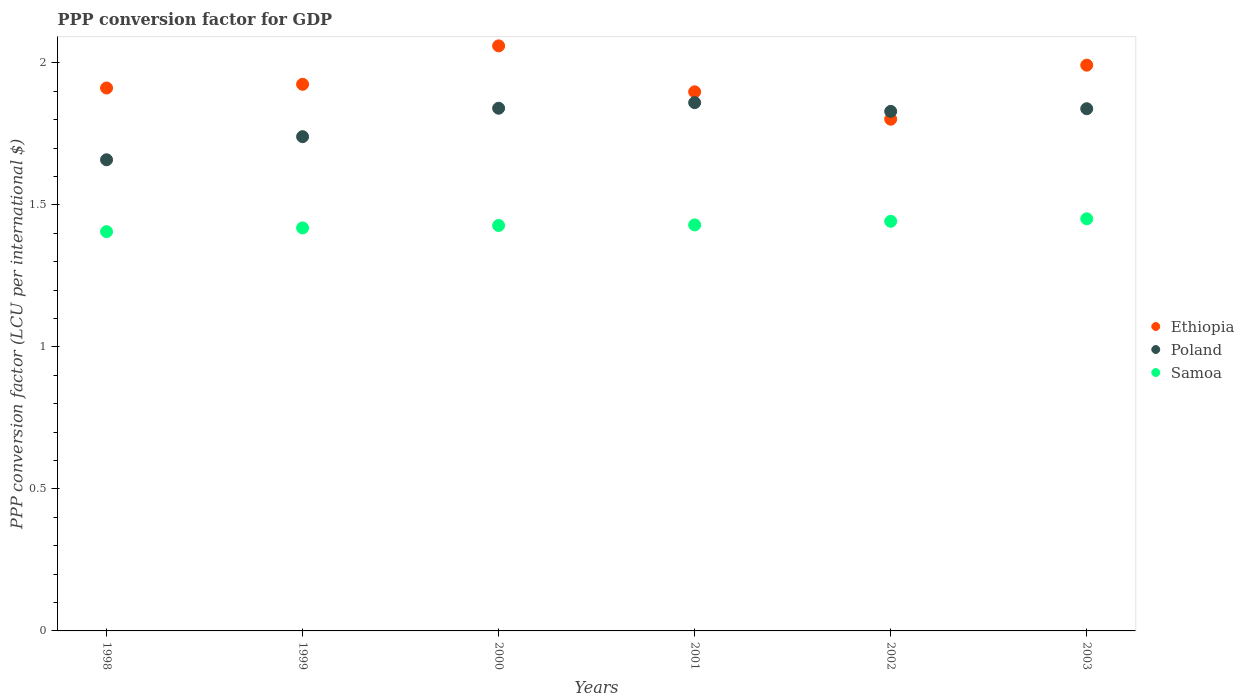How many different coloured dotlines are there?
Offer a terse response. 3. What is the PPP conversion factor for GDP in Poland in 2003?
Your answer should be compact. 1.84. Across all years, what is the maximum PPP conversion factor for GDP in Samoa?
Offer a terse response. 1.45. Across all years, what is the minimum PPP conversion factor for GDP in Ethiopia?
Provide a short and direct response. 1.8. In which year was the PPP conversion factor for GDP in Ethiopia minimum?
Keep it short and to the point. 2002. What is the total PPP conversion factor for GDP in Ethiopia in the graph?
Your response must be concise. 11.59. What is the difference between the PPP conversion factor for GDP in Ethiopia in 1998 and that in 1999?
Keep it short and to the point. -0.01. What is the difference between the PPP conversion factor for GDP in Samoa in 2002 and the PPP conversion factor for GDP in Ethiopia in 2003?
Your answer should be very brief. -0.55. What is the average PPP conversion factor for GDP in Poland per year?
Give a very brief answer. 1.79. In the year 2002, what is the difference between the PPP conversion factor for GDP in Samoa and PPP conversion factor for GDP in Poland?
Keep it short and to the point. -0.39. What is the ratio of the PPP conversion factor for GDP in Ethiopia in 1999 to that in 2003?
Your answer should be very brief. 0.97. What is the difference between the highest and the second highest PPP conversion factor for GDP in Poland?
Your answer should be compact. 0.02. What is the difference between the highest and the lowest PPP conversion factor for GDP in Ethiopia?
Make the answer very short. 0.26. In how many years, is the PPP conversion factor for GDP in Ethiopia greater than the average PPP conversion factor for GDP in Ethiopia taken over all years?
Ensure brevity in your answer.  2. Is the PPP conversion factor for GDP in Samoa strictly greater than the PPP conversion factor for GDP in Poland over the years?
Your response must be concise. No. Is the PPP conversion factor for GDP in Ethiopia strictly less than the PPP conversion factor for GDP in Poland over the years?
Your response must be concise. No. How many dotlines are there?
Make the answer very short. 3. What is the difference between two consecutive major ticks on the Y-axis?
Offer a terse response. 0.5. Are the values on the major ticks of Y-axis written in scientific E-notation?
Give a very brief answer. No. Does the graph contain any zero values?
Ensure brevity in your answer.  No. Where does the legend appear in the graph?
Make the answer very short. Center right. What is the title of the graph?
Give a very brief answer. PPP conversion factor for GDP. Does "Euro area" appear as one of the legend labels in the graph?
Offer a very short reply. No. What is the label or title of the Y-axis?
Keep it short and to the point. PPP conversion factor (LCU per international $). What is the PPP conversion factor (LCU per international $) in Ethiopia in 1998?
Offer a very short reply. 1.91. What is the PPP conversion factor (LCU per international $) of Poland in 1998?
Your answer should be very brief. 1.66. What is the PPP conversion factor (LCU per international $) in Samoa in 1998?
Provide a short and direct response. 1.41. What is the PPP conversion factor (LCU per international $) in Ethiopia in 1999?
Your answer should be very brief. 1.92. What is the PPP conversion factor (LCU per international $) in Poland in 1999?
Ensure brevity in your answer.  1.74. What is the PPP conversion factor (LCU per international $) of Samoa in 1999?
Give a very brief answer. 1.42. What is the PPP conversion factor (LCU per international $) in Ethiopia in 2000?
Give a very brief answer. 2.06. What is the PPP conversion factor (LCU per international $) of Poland in 2000?
Provide a succinct answer. 1.84. What is the PPP conversion factor (LCU per international $) in Samoa in 2000?
Your response must be concise. 1.43. What is the PPP conversion factor (LCU per international $) of Ethiopia in 2001?
Make the answer very short. 1.9. What is the PPP conversion factor (LCU per international $) of Poland in 2001?
Provide a succinct answer. 1.86. What is the PPP conversion factor (LCU per international $) of Samoa in 2001?
Your answer should be very brief. 1.43. What is the PPP conversion factor (LCU per international $) of Ethiopia in 2002?
Offer a very short reply. 1.8. What is the PPP conversion factor (LCU per international $) of Poland in 2002?
Provide a succinct answer. 1.83. What is the PPP conversion factor (LCU per international $) of Samoa in 2002?
Offer a very short reply. 1.44. What is the PPP conversion factor (LCU per international $) of Ethiopia in 2003?
Ensure brevity in your answer.  1.99. What is the PPP conversion factor (LCU per international $) in Poland in 2003?
Give a very brief answer. 1.84. What is the PPP conversion factor (LCU per international $) in Samoa in 2003?
Your response must be concise. 1.45. Across all years, what is the maximum PPP conversion factor (LCU per international $) of Ethiopia?
Ensure brevity in your answer.  2.06. Across all years, what is the maximum PPP conversion factor (LCU per international $) of Poland?
Keep it short and to the point. 1.86. Across all years, what is the maximum PPP conversion factor (LCU per international $) in Samoa?
Your answer should be very brief. 1.45. Across all years, what is the minimum PPP conversion factor (LCU per international $) of Ethiopia?
Your answer should be compact. 1.8. Across all years, what is the minimum PPP conversion factor (LCU per international $) of Poland?
Provide a succinct answer. 1.66. Across all years, what is the minimum PPP conversion factor (LCU per international $) of Samoa?
Your answer should be compact. 1.41. What is the total PPP conversion factor (LCU per international $) in Ethiopia in the graph?
Give a very brief answer. 11.59. What is the total PPP conversion factor (LCU per international $) in Poland in the graph?
Your response must be concise. 10.77. What is the total PPP conversion factor (LCU per international $) of Samoa in the graph?
Ensure brevity in your answer.  8.57. What is the difference between the PPP conversion factor (LCU per international $) of Ethiopia in 1998 and that in 1999?
Provide a short and direct response. -0.01. What is the difference between the PPP conversion factor (LCU per international $) in Poland in 1998 and that in 1999?
Your answer should be very brief. -0.08. What is the difference between the PPP conversion factor (LCU per international $) in Samoa in 1998 and that in 1999?
Your answer should be very brief. -0.01. What is the difference between the PPP conversion factor (LCU per international $) in Ethiopia in 1998 and that in 2000?
Give a very brief answer. -0.15. What is the difference between the PPP conversion factor (LCU per international $) in Poland in 1998 and that in 2000?
Keep it short and to the point. -0.18. What is the difference between the PPP conversion factor (LCU per international $) of Samoa in 1998 and that in 2000?
Provide a succinct answer. -0.02. What is the difference between the PPP conversion factor (LCU per international $) in Ethiopia in 1998 and that in 2001?
Provide a succinct answer. 0.01. What is the difference between the PPP conversion factor (LCU per international $) of Poland in 1998 and that in 2001?
Offer a terse response. -0.2. What is the difference between the PPP conversion factor (LCU per international $) of Samoa in 1998 and that in 2001?
Offer a terse response. -0.02. What is the difference between the PPP conversion factor (LCU per international $) in Ethiopia in 1998 and that in 2002?
Offer a very short reply. 0.11. What is the difference between the PPP conversion factor (LCU per international $) in Poland in 1998 and that in 2002?
Ensure brevity in your answer.  -0.17. What is the difference between the PPP conversion factor (LCU per international $) in Samoa in 1998 and that in 2002?
Your response must be concise. -0.04. What is the difference between the PPP conversion factor (LCU per international $) in Ethiopia in 1998 and that in 2003?
Offer a terse response. -0.08. What is the difference between the PPP conversion factor (LCU per international $) in Poland in 1998 and that in 2003?
Your response must be concise. -0.18. What is the difference between the PPP conversion factor (LCU per international $) of Samoa in 1998 and that in 2003?
Your answer should be compact. -0.05. What is the difference between the PPP conversion factor (LCU per international $) in Ethiopia in 1999 and that in 2000?
Ensure brevity in your answer.  -0.14. What is the difference between the PPP conversion factor (LCU per international $) in Poland in 1999 and that in 2000?
Offer a terse response. -0.1. What is the difference between the PPP conversion factor (LCU per international $) of Samoa in 1999 and that in 2000?
Provide a short and direct response. -0.01. What is the difference between the PPP conversion factor (LCU per international $) of Ethiopia in 1999 and that in 2001?
Your answer should be compact. 0.03. What is the difference between the PPP conversion factor (LCU per international $) in Poland in 1999 and that in 2001?
Keep it short and to the point. -0.12. What is the difference between the PPP conversion factor (LCU per international $) in Samoa in 1999 and that in 2001?
Provide a succinct answer. -0.01. What is the difference between the PPP conversion factor (LCU per international $) of Ethiopia in 1999 and that in 2002?
Your answer should be compact. 0.12. What is the difference between the PPP conversion factor (LCU per international $) of Poland in 1999 and that in 2002?
Offer a terse response. -0.09. What is the difference between the PPP conversion factor (LCU per international $) in Samoa in 1999 and that in 2002?
Keep it short and to the point. -0.02. What is the difference between the PPP conversion factor (LCU per international $) in Ethiopia in 1999 and that in 2003?
Ensure brevity in your answer.  -0.07. What is the difference between the PPP conversion factor (LCU per international $) in Poland in 1999 and that in 2003?
Offer a terse response. -0.1. What is the difference between the PPP conversion factor (LCU per international $) of Samoa in 1999 and that in 2003?
Provide a succinct answer. -0.03. What is the difference between the PPP conversion factor (LCU per international $) in Ethiopia in 2000 and that in 2001?
Keep it short and to the point. 0.16. What is the difference between the PPP conversion factor (LCU per international $) of Poland in 2000 and that in 2001?
Provide a short and direct response. -0.02. What is the difference between the PPP conversion factor (LCU per international $) in Samoa in 2000 and that in 2001?
Your answer should be compact. -0. What is the difference between the PPP conversion factor (LCU per international $) of Ethiopia in 2000 and that in 2002?
Provide a succinct answer. 0.26. What is the difference between the PPP conversion factor (LCU per international $) of Poland in 2000 and that in 2002?
Provide a short and direct response. 0.01. What is the difference between the PPP conversion factor (LCU per international $) of Samoa in 2000 and that in 2002?
Make the answer very short. -0.01. What is the difference between the PPP conversion factor (LCU per international $) in Ethiopia in 2000 and that in 2003?
Offer a very short reply. 0.07. What is the difference between the PPP conversion factor (LCU per international $) of Poland in 2000 and that in 2003?
Keep it short and to the point. 0. What is the difference between the PPP conversion factor (LCU per international $) of Samoa in 2000 and that in 2003?
Keep it short and to the point. -0.02. What is the difference between the PPP conversion factor (LCU per international $) in Ethiopia in 2001 and that in 2002?
Your answer should be very brief. 0.1. What is the difference between the PPP conversion factor (LCU per international $) in Poland in 2001 and that in 2002?
Give a very brief answer. 0.03. What is the difference between the PPP conversion factor (LCU per international $) in Samoa in 2001 and that in 2002?
Offer a very short reply. -0.01. What is the difference between the PPP conversion factor (LCU per international $) in Ethiopia in 2001 and that in 2003?
Provide a succinct answer. -0.09. What is the difference between the PPP conversion factor (LCU per international $) of Poland in 2001 and that in 2003?
Provide a short and direct response. 0.02. What is the difference between the PPP conversion factor (LCU per international $) of Samoa in 2001 and that in 2003?
Offer a very short reply. -0.02. What is the difference between the PPP conversion factor (LCU per international $) of Ethiopia in 2002 and that in 2003?
Your response must be concise. -0.19. What is the difference between the PPP conversion factor (LCU per international $) of Poland in 2002 and that in 2003?
Your answer should be compact. -0.01. What is the difference between the PPP conversion factor (LCU per international $) in Samoa in 2002 and that in 2003?
Offer a very short reply. -0.01. What is the difference between the PPP conversion factor (LCU per international $) in Ethiopia in 1998 and the PPP conversion factor (LCU per international $) in Poland in 1999?
Keep it short and to the point. 0.17. What is the difference between the PPP conversion factor (LCU per international $) in Ethiopia in 1998 and the PPP conversion factor (LCU per international $) in Samoa in 1999?
Give a very brief answer. 0.49. What is the difference between the PPP conversion factor (LCU per international $) in Poland in 1998 and the PPP conversion factor (LCU per international $) in Samoa in 1999?
Your answer should be very brief. 0.24. What is the difference between the PPP conversion factor (LCU per international $) in Ethiopia in 1998 and the PPP conversion factor (LCU per international $) in Poland in 2000?
Your response must be concise. 0.07. What is the difference between the PPP conversion factor (LCU per international $) in Ethiopia in 1998 and the PPP conversion factor (LCU per international $) in Samoa in 2000?
Keep it short and to the point. 0.48. What is the difference between the PPP conversion factor (LCU per international $) in Poland in 1998 and the PPP conversion factor (LCU per international $) in Samoa in 2000?
Offer a terse response. 0.23. What is the difference between the PPP conversion factor (LCU per international $) in Ethiopia in 1998 and the PPP conversion factor (LCU per international $) in Poland in 2001?
Provide a succinct answer. 0.05. What is the difference between the PPP conversion factor (LCU per international $) of Ethiopia in 1998 and the PPP conversion factor (LCU per international $) of Samoa in 2001?
Make the answer very short. 0.48. What is the difference between the PPP conversion factor (LCU per international $) of Poland in 1998 and the PPP conversion factor (LCU per international $) of Samoa in 2001?
Your response must be concise. 0.23. What is the difference between the PPP conversion factor (LCU per international $) of Ethiopia in 1998 and the PPP conversion factor (LCU per international $) of Poland in 2002?
Make the answer very short. 0.08. What is the difference between the PPP conversion factor (LCU per international $) of Ethiopia in 1998 and the PPP conversion factor (LCU per international $) of Samoa in 2002?
Your answer should be very brief. 0.47. What is the difference between the PPP conversion factor (LCU per international $) in Poland in 1998 and the PPP conversion factor (LCU per international $) in Samoa in 2002?
Give a very brief answer. 0.22. What is the difference between the PPP conversion factor (LCU per international $) in Ethiopia in 1998 and the PPP conversion factor (LCU per international $) in Poland in 2003?
Keep it short and to the point. 0.07. What is the difference between the PPP conversion factor (LCU per international $) of Ethiopia in 1998 and the PPP conversion factor (LCU per international $) of Samoa in 2003?
Provide a short and direct response. 0.46. What is the difference between the PPP conversion factor (LCU per international $) in Poland in 1998 and the PPP conversion factor (LCU per international $) in Samoa in 2003?
Offer a very short reply. 0.21. What is the difference between the PPP conversion factor (LCU per international $) of Ethiopia in 1999 and the PPP conversion factor (LCU per international $) of Poland in 2000?
Keep it short and to the point. 0.08. What is the difference between the PPP conversion factor (LCU per international $) of Ethiopia in 1999 and the PPP conversion factor (LCU per international $) of Samoa in 2000?
Your response must be concise. 0.5. What is the difference between the PPP conversion factor (LCU per international $) of Poland in 1999 and the PPP conversion factor (LCU per international $) of Samoa in 2000?
Your answer should be compact. 0.31. What is the difference between the PPP conversion factor (LCU per international $) of Ethiopia in 1999 and the PPP conversion factor (LCU per international $) of Poland in 2001?
Provide a succinct answer. 0.06. What is the difference between the PPP conversion factor (LCU per international $) of Ethiopia in 1999 and the PPP conversion factor (LCU per international $) of Samoa in 2001?
Provide a succinct answer. 0.49. What is the difference between the PPP conversion factor (LCU per international $) in Poland in 1999 and the PPP conversion factor (LCU per international $) in Samoa in 2001?
Your answer should be very brief. 0.31. What is the difference between the PPP conversion factor (LCU per international $) in Ethiopia in 1999 and the PPP conversion factor (LCU per international $) in Poland in 2002?
Give a very brief answer. 0.1. What is the difference between the PPP conversion factor (LCU per international $) in Ethiopia in 1999 and the PPP conversion factor (LCU per international $) in Samoa in 2002?
Provide a short and direct response. 0.48. What is the difference between the PPP conversion factor (LCU per international $) of Poland in 1999 and the PPP conversion factor (LCU per international $) of Samoa in 2002?
Provide a short and direct response. 0.3. What is the difference between the PPP conversion factor (LCU per international $) of Ethiopia in 1999 and the PPP conversion factor (LCU per international $) of Poland in 2003?
Make the answer very short. 0.09. What is the difference between the PPP conversion factor (LCU per international $) in Ethiopia in 1999 and the PPP conversion factor (LCU per international $) in Samoa in 2003?
Offer a terse response. 0.47. What is the difference between the PPP conversion factor (LCU per international $) of Poland in 1999 and the PPP conversion factor (LCU per international $) of Samoa in 2003?
Make the answer very short. 0.29. What is the difference between the PPP conversion factor (LCU per international $) in Ethiopia in 2000 and the PPP conversion factor (LCU per international $) in Poland in 2001?
Ensure brevity in your answer.  0.2. What is the difference between the PPP conversion factor (LCU per international $) in Ethiopia in 2000 and the PPP conversion factor (LCU per international $) in Samoa in 2001?
Provide a short and direct response. 0.63. What is the difference between the PPP conversion factor (LCU per international $) of Poland in 2000 and the PPP conversion factor (LCU per international $) of Samoa in 2001?
Offer a very short reply. 0.41. What is the difference between the PPP conversion factor (LCU per international $) of Ethiopia in 2000 and the PPP conversion factor (LCU per international $) of Poland in 2002?
Provide a succinct answer. 0.23. What is the difference between the PPP conversion factor (LCU per international $) in Ethiopia in 2000 and the PPP conversion factor (LCU per international $) in Samoa in 2002?
Your response must be concise. 0.62. What is the difference between the PPP conversion factor (LCU per international $) of Poland in 2000 and the PPP conversion factor (LCU per international $) of Samoa in 2002?
Make the answer very short. 0.4. What is the difference between the PPP conversion factor (LCU per international $) of Ethiopia in 2000 and the PPP conversion factor (LCU per international $) of Poland in 2003?
Offer a terse response. 0.22. What is the difference between the PPP conversion factor (LCU per international $) in Ethiopia in 2000 and the PPP conversion factor (LCU per international $) in Samoa in 2003?
Make the answer very short. 0.61. What is the difference between the PPP conversion factor (LCU per international $) of Poland in 2000 and the PPP conversion factor (LCU per international $) of Samoa in 2003?
Provide a succinct answer. 0.39. What is the difference between the PPP conversion factor (LCU per international $) of Ethiopia in 2001 and the PPP conversion factor (LCU per international $) of Poland in 2002?
Ensure brevity in your answer.  0.07. What is the difference between the PPP conversion factor (LCU per international $) of Ethiopia in 2001 and the PPP conversion factor (LCU per international $) of Samoa in 2002?
Offer a very short reply. 0.46. What is the difference between the PPP conversion factor (LCU per international $) of Poland in 2001 and the PPP conversion factor (LCU per international $) of Samoa in 2002?
Provide a succinct answer. 0.42. What is the difference between the PPP conversion factor (LCU per international $) of Ethiopia in 2001 and the PPP conversion factor (LCU per international $) of Poland in 2003?
Offer a very short reply. 0.06. What is the difference between the PPP conversion factor (LCU per international $) in Ethiopia in 2001 and the PPP conversion factor (LCU per international $) in Samoa in 2003?
Ensure brevity in your answer.  0.45. What is the difference between the PPP conversion factor (LCU per international $) in Poland in 2001 and the PPP conversion factor (LCU per international $) in Samoa in 2003?
Your response must be concise. 0.41. What is the difference between the PPP conversion factor (LCU per international $) of Ethiopia in 2002 and the PPP conversion factor (LCU per international $) of Poland in 2003?
Provide a short and direct response. -0.04. What is the difference between the PPP conversion factor (LCU per international $) in Ethiopia in 2002 and the PPP conversion factor (LCU per international $) in Samoa in 2003?
Your answer should be very brief. 0.35. What is the difference between the PPP conversion factor (LCU per international $) in Poland in 2002 and the PPP conversion factor (LCU per international $) in Samoa in 2003?
Provide a short and direct response. 0.38. What is the average PPP conversion factor (LCU per international $) in Ethiopia per year?
Provide a succinct answer. 1.93. What is the average PPP conversion factor (LCU per international $) in Poland per year?
Provide a succinct answer. 1.79. What is the average PPP conversion factor (LCU per international $) in Samoa per year?
Your answer should be very brief. 1.43. In the year 1998, what is the difference between the PPP conversion factor (LCU per international $) in Ethiopia and PPP conversion factor (LCU per international $) in Poland?
Your response must be concise. 0.25. In the year 1998, what is the difference between the PPP conversion factor (LCU per international $) in Ethiopia and PPP conversion factor (LCU per international $) in Samoa?
Give a very brief answer. 0.51. In the year 1998, what is the difference between the PPP conversion factor (LCU per international $) in Poland and PPP conversion factor (LCU per international $) in Samoa?
Your response must be concise. 0.25. In the year 1999, what is the difference between the PPP conversion factor (LCU per international $) of Ethiopia and PPP conversion factor (LCU per international $) of Poland?
Your answer should be compact. 0.18. In the year 1999, what is the difference between the PPP conversion factor (LCU per international $) of Ethiopia and PPP conversion factor (LCU per international $) of Samoa?
Provide a short and direct response. 0.51. In the year 1999, what is the difference between the PPP conversion factor (LCU per international $) in Poland and PPP conversion factor (LCU per international $) in Samoa?
Offer a very short reply. 0.32. In the year 2000, what is the difference between the PPP conversion factor (LCU per international $) in Ethiopia and PPP conversion factor (LCU per international $) in Poland?
Ensure brevity in your answer.  0.22. In the year 2000, what is the difference between the PPP conversion factor (LCU per international $) of Ethiopia and PPP conversion factor (LCU per international $) of Samoa?
Make the answer very short. 0.63. In the year 2000, what is the difference between the PPP conversion factor (LCU per international $) of Poland and PPP conversion factor (LCU per international $) of Samoa?
Keep it short and to the point. 0.41. In the year 2001, what is the difference between the PPP conversion factor (LCU per international $) in Ethiopia and PPP conversion factor (LCU per international $) in Poland?
Your response must be concise. 0.04. In the year 2001, what is the difference between the PPP conversion factor (LCU per international $) of Ethiopia and PPP conversion factor (LCU per international $) of Samoa?
Your response must be concise. 0.47. In the year 2001, what is the difference between the PPP conversion factor (LCU per international $) in Poland and PPP conversion factor (LCU per international $) in Samoa?
Your answer should be very brief. 0.43. In the year 2002, what is the difference between the PPP conversion factor (LCU per international $) in Ethiopia and PPP conversion factor (LCU per international $) in Poland?
Make the answer very short. -0.03. In the year 2002, what is the difference between the PPP conversion factor (LCU per international $) in Ethiopia and PPP conversion factor (LCU per international $) in Samoa?
Your answer should be compact. 0.36. In the year 2002, what is the difference between the PPP conversion factor (LCU per international $) of Poland and PPP conversion factor (LCU per international $) of Samoa?
Offer a very short reply. 0.39. In the year 2003, what is the difference between the PPP conversion factor (LCU per international $) in Ethiopia and PPP conversion factor (LCU per international $) in Poland?
Your answer should be compact. 0.15. In the year 2003, what is the difference between the PPP conversion factor (LCU per international $) of Ethiopia and PPP conversion factor (LCU per international $) of Samoa?
Your response must be concise. 0.54. In the year 2003, what is the difference between the PPP conversion factor (LCU per international $) of Poland and PPP conversion factor (LCU per international $) of Samoa?
Give a very brief answer. 0.39. What is the ratio of the PPP conversion factor (LCU per international $) in Ethiopia in 1998 to that in 1999?
Ensure brevity in your answer.  0.99. What is the ratio of the PPP conversion factor (LCU per international $) in Poland in 1998 to that in 1999?
Your response must be concise. 0.95. What is the ratio of the PPP conversion factor (LCU per international $) of Samoa in 1998 to that in 1999?
Your response must be concise. 0.99. What is the ratio of the PPP conversion factor (LCU per international $) in Ethiopia in 1998 to that in 2000?
Provide a succinct answer. 0.93. What is the ratio of the PPP conversion factor (LCU per international $) in Poland in 1998 to that in 2000?
Make the answer very short. 0.9. What is the ratio of the PPP conversion factor (LCU per international $) in Ethiopia in 1998 to that in 2001?
Your response must be concise. 1.01. What is the ratio of the PPP conversion factor (LCU per international $) in Poland in 1998 to that in 2001?
Make the answer very short. 0.89. What is the ratio of the PPP conversion factor (LCU per international $) of Samoa in 1998 to that in 2001?
Give a very brief answer. 0.98. What is the ratio of the PPP conversion factor (LCU per international $) of Ethiopia in 1998 to that in 2002?
Offer a very short reply. 1.06. What is the ratio of the PPP conversion factor (LCU per international $) in Poland in 1998 to that in 2002?
Ensure brevity in your answer.  0.91. What is the ratio of the PPP conversion factor (LCU per international $) of Samoa in 1998 to that in 2002?
Provide a succinct answer. 0.97. What is the ratio of the PPP conversion factor (LCU per international $) in Ethiopia in 1998 to that in 2003?
Your answer should be very brief. 0.96. What is the ratio of the PPP conversion factor (LCU per international $) of Poland in 1998 to that in 2003?
Your answer should be very brief. 0.9. What is the ratio of the PPP conversion factor (LCU per international $) of Samoa in 1998 to that in 2003?
Your response must be concise. 0.97. What is the ratio of the PPP conversion factor (LCU per international $) of Ethiopia in 1999 to that in 2000?
Your answer should be very brief. 0.93. What is the ratio of the PPP conversion factor (LCU per international $) of Poland in 1999 to that in 2000?
Offer a very short reply. 0.95. What is the ratio of the PPP conversion factor (LCU per international $) in Poland in 1999 to that in 2001?
Keep it short and to the point. 0.94. What is the ratio of the PPP conversion factor (LCU per international $) of Samoa in 1999 to that in 2001?
Your answer should be compact. 0.99. What is the ratio of the PPP conversion factor (LCU per international $) of Ethiopia in 1999 to that in 2002?
Provide a succinct answer. 1.07. What is the ratio of the PPP conversion factor (LCU per international $) of Poland in 1999 to that in 2002?
Provide a short and direct response. 0.95. What is the ratio of the PPP conversion factor (LCU per international $) in Samoa in 1999 to that in 2002?
Your answer should be very brief. 0.98. What is the ratio of the PPP conversion factor (LCU per international $) in Ethiopia in 1999 to that in 2003?
Offer a terse response. 0.97. What is the ratio of the PPP conversion factor (LCU per international $) of Poland in 1999 to that in 2003?
Your response must be concise. 0.95. What is the ratio of the PPP conversion factor (LCU per international $) of Samoa in 1999 to that in 2003?
Ensure brevity in your answer.  0.98. What is the ratio of the PPP conversion factor (LCU per international $) in Ethiopia in 2000 to that in 2001?
Ensure brevity in your answer.  1.09. What is the ratio of the PPP conversion factor (LCU per international $) of Ethiopia in 2000 to that in 2002?
Offer a terse response. 1.14. What is the ratio of the PPP conversion factor (LCU per international $) of Ethiopia in 2000 to that in 2003?
Your answer should be very brief. 1.03. What is the ratio of the PPP conversion factor (LCU per international $) of Samoa in 2000 to that in 2003?
Your answer should be very brief. 0.98. What is the ratio of the PPP conversion factor (LCU per international $) of Ethiopia in 2001 to that in 2002?
Offer a terse response. 1.05. What is the ratio of the PPP conversion factor (LCU per international $) in Poland in 2001 to that in 2002?
Your response must be concise. 1.02. What is the ratio of the PPP conversion factor (LCU per international $) in Samoa in 2001 to that in 2002?
Provide a short and direct response. 0.99. What is the ratio of the PPP conversion factor (LCU per international $) of Ethiopia in 2001 to that in 2003?
Provide a short and direct response. 0.95. What is the ratio of the PPP conversion factor (LCU per international $) in Poland in 2001 to that in 2003?
Your response must be concise. 1.01. What is the ratio of the PPP conversion factor (LCU per international $) in Samoa in 2001 to that in 2003?
Offer a terse response. 0.99. What is the ratio of the PPP conversion factor (LCU per international $) in Ethiopia in 2002 to that in 2003?
Your answer should be compact. 0.9. What is the ratio of the PPP conversion factor (LCU per international $) in Samoa in 2002 to that in 2003?
Make the answer very short. 0.99. What is the difference between the highest and the second highest PPP conversion factor (LCU per international $) of Ethiopia?
Your answer should be compact. 0.07. What is the difference between the highest and the second highest PPP conversion factor (LCU per international $) of Poland?
Offer a very short reply. 0.02. What is the difference between the highest and the second highest PPP conversion factor (LCU per international $) in Samoa?
Ensure brevity in your answer.  0.01. What is the difference between the highest and the lowest PPP conversion factor (LCU per international $) in Ethiopia?
Your answer should be compact. 0.26. What is the difference between the highest and the lowest PPP conversion factor (LCU per international $) of Poland?
Provide a short and direct response. 0.2. What is the difference between the highest and the lowest PPP conversion factor (LCU per international $) of Samoa?
Provide a short and direct response. 0.05. 